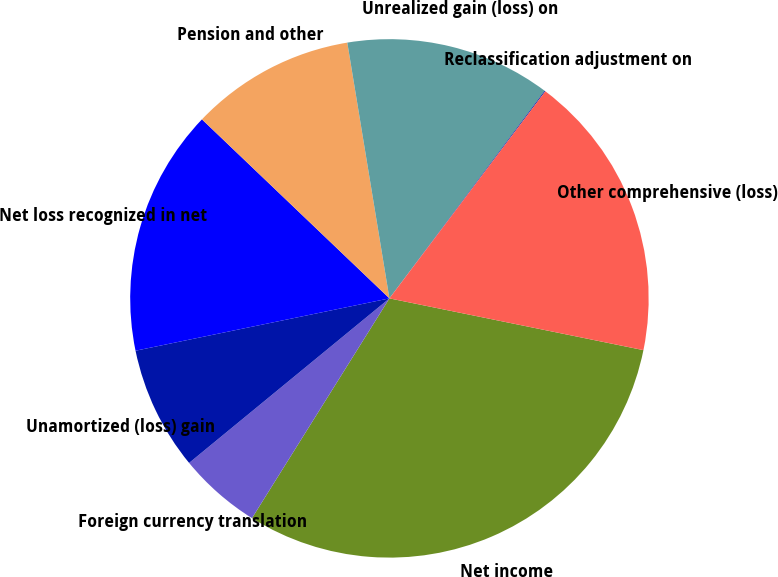Convert chart to OTSL. <chart><loc_0><loc_0><loc_500><loc_500><pie_chart><fcel>Net income<fcel>Foreign currency translation<fcel>Unamortized (loss) gain<fcel>Net loss recognized in net<fcel>Pension and other<fcel>Unrealized gain (loss) on<fcel>Reclassification adjustment on<fcel>Other comprehensive (loss)<nl><fcel>30.7%<fcel>5.16%<fcel>7.71%<fcel>15.37%<fcel>10.27%<fcel>12.82%<fcel>0.05%<fcel>17.93%<nl></chart> 